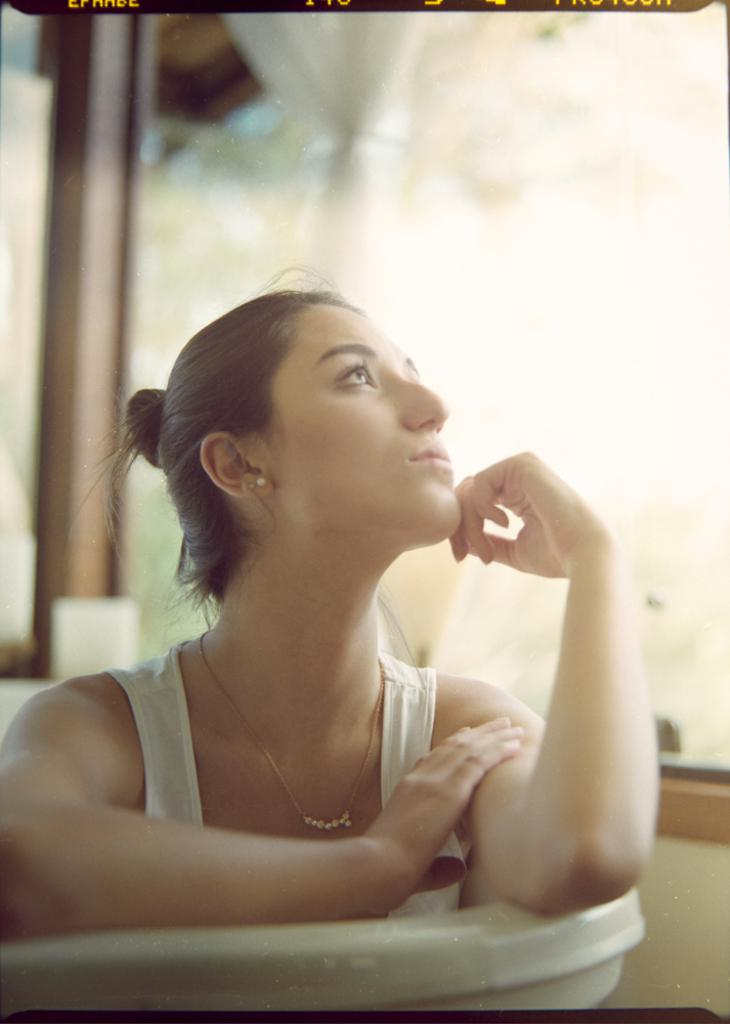Who is present in the image? There is a woman in the image. What is the woman doing in the image? The woman is in a bathtub in the image. What can be seen through the window in the image? Unfortunately, the facts provided do not mention anything about the window or what can be seen through it. What type of zinc is being used to build the can in the image? There is no can present in the image, and therefore no zinc can be observed. 